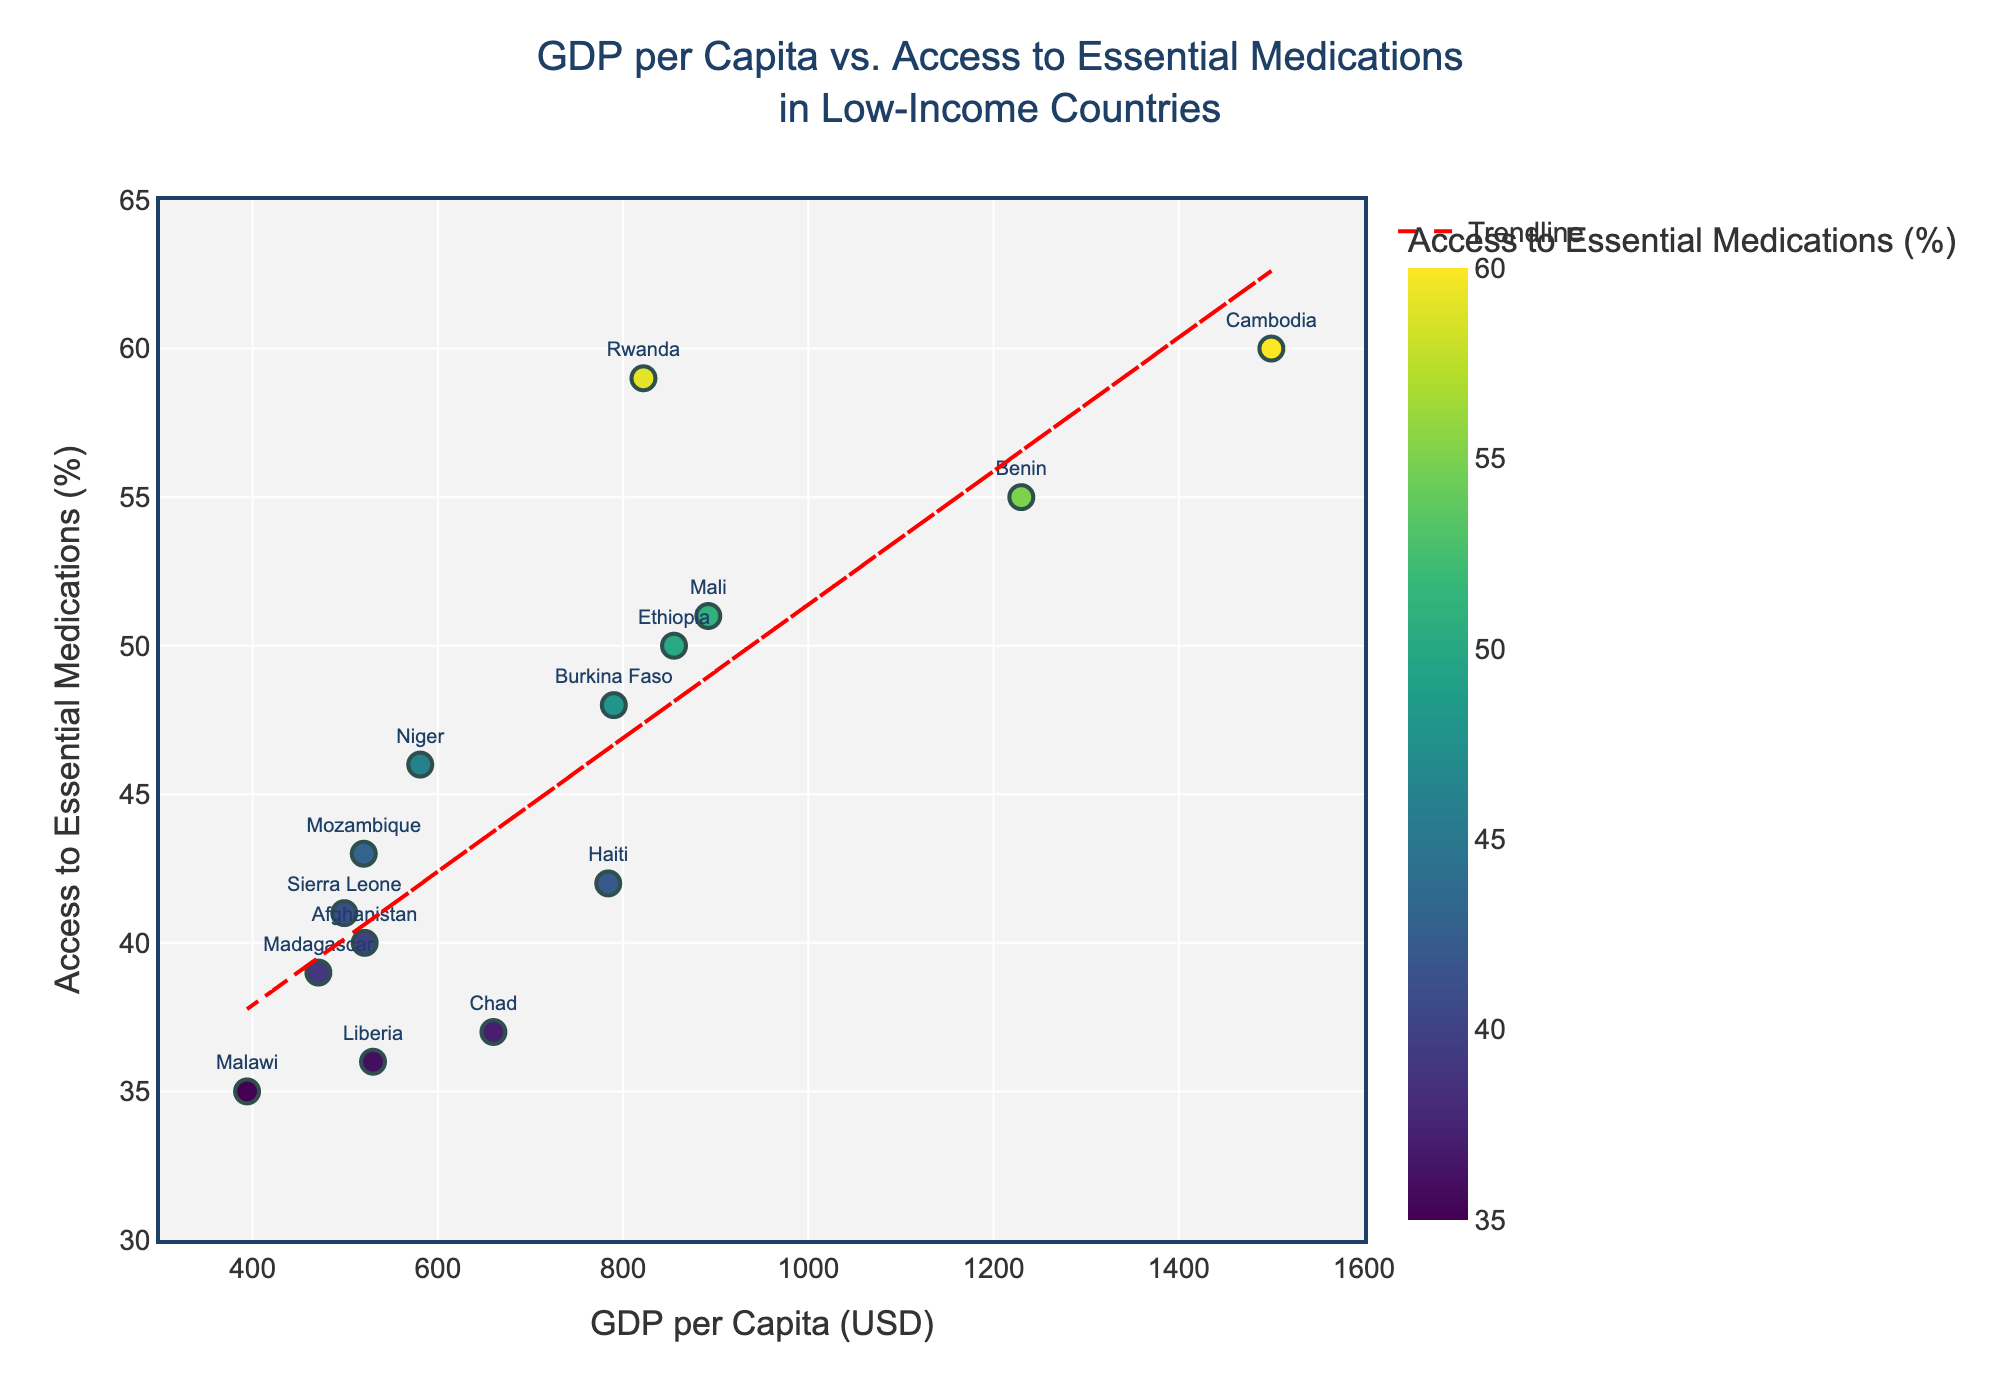What's the GDP per capita of the country with the highest access to essential medications? The country with the highest access to essential medications (60%) is Cambodia. The corresponding GDP per capita seen on the x-axis for Cambodia is $1500.
Answer: $1500 Which country has the lowest GDP per capita and what is its access to essential medications? The country with the lowest GDP per capita (seen on the x-axis) is Malawi at $394. The access to essential medications (seen on the y-axis) for Malawi is 35%.
Answer: Malawi, 35% Is there a trend between GDP per capita and access to essential medications? Yes, there is a trend line added in red with a dashed pattern that shows a positive relationship, indicating that as GDP per capita increases, access to essential medications also tends to increase.
Answer: Positive trend How many countries have a GDP per capita below $500? By observing the data points to the left of the $500 mark on the x-axis, we see Afghanistan, Madagascar, Malawi, and Sierra Leone. This counts to 4 countries.
Answer: 4 Compare the access to essential medications between Mozambique and Niger. By checking the data points, Mozambique has 43% access whereas Niger has 46% access. Niger has a slightly higher access to essential medications than Mozambique.
Answer: Niger has higher What is the approximate range of access to essential medications for countries with a GDP per capita above $1000? By looking at the data points to the right of the $1000 mark on the x-axis, Benin (55%) and Cambodia (60%) are the countries. This range is from 55% to 60%.
Answer: 55% to 60% Which country has a GDP per capita closest to $850, and what is its access to essential medications? Looking near the $850 mark on the x-axis, Ethiopia has a GDP per capita of $855 and its corresponding access to essential medications is 50%.
Answer: Ethiopia, 50% On average, do countries with higher GDP per capita have better access to essential medications? Observing the scatter plot, most countries with higher GDP per capita (right side of the plot) seem to have higher access percentages. The trend line also supports this observation.
Answer: Yes Is there any country with a GDP per capita between $700 and $800, and what is its access to essential medications? Burkina Faso has a GDP per capita within this range (790), with an access to essential medications of 48%.
Answer: Burkina Faso, 48% How does Liberia compare to Sierra Leone in terms of access to essential medications? Liberia has an access rate of 36%, while Sierra Leone has 41%. Sierra Leone has better access to essential medications compared to Liberia.
Answer: Sierra Leone has higher 